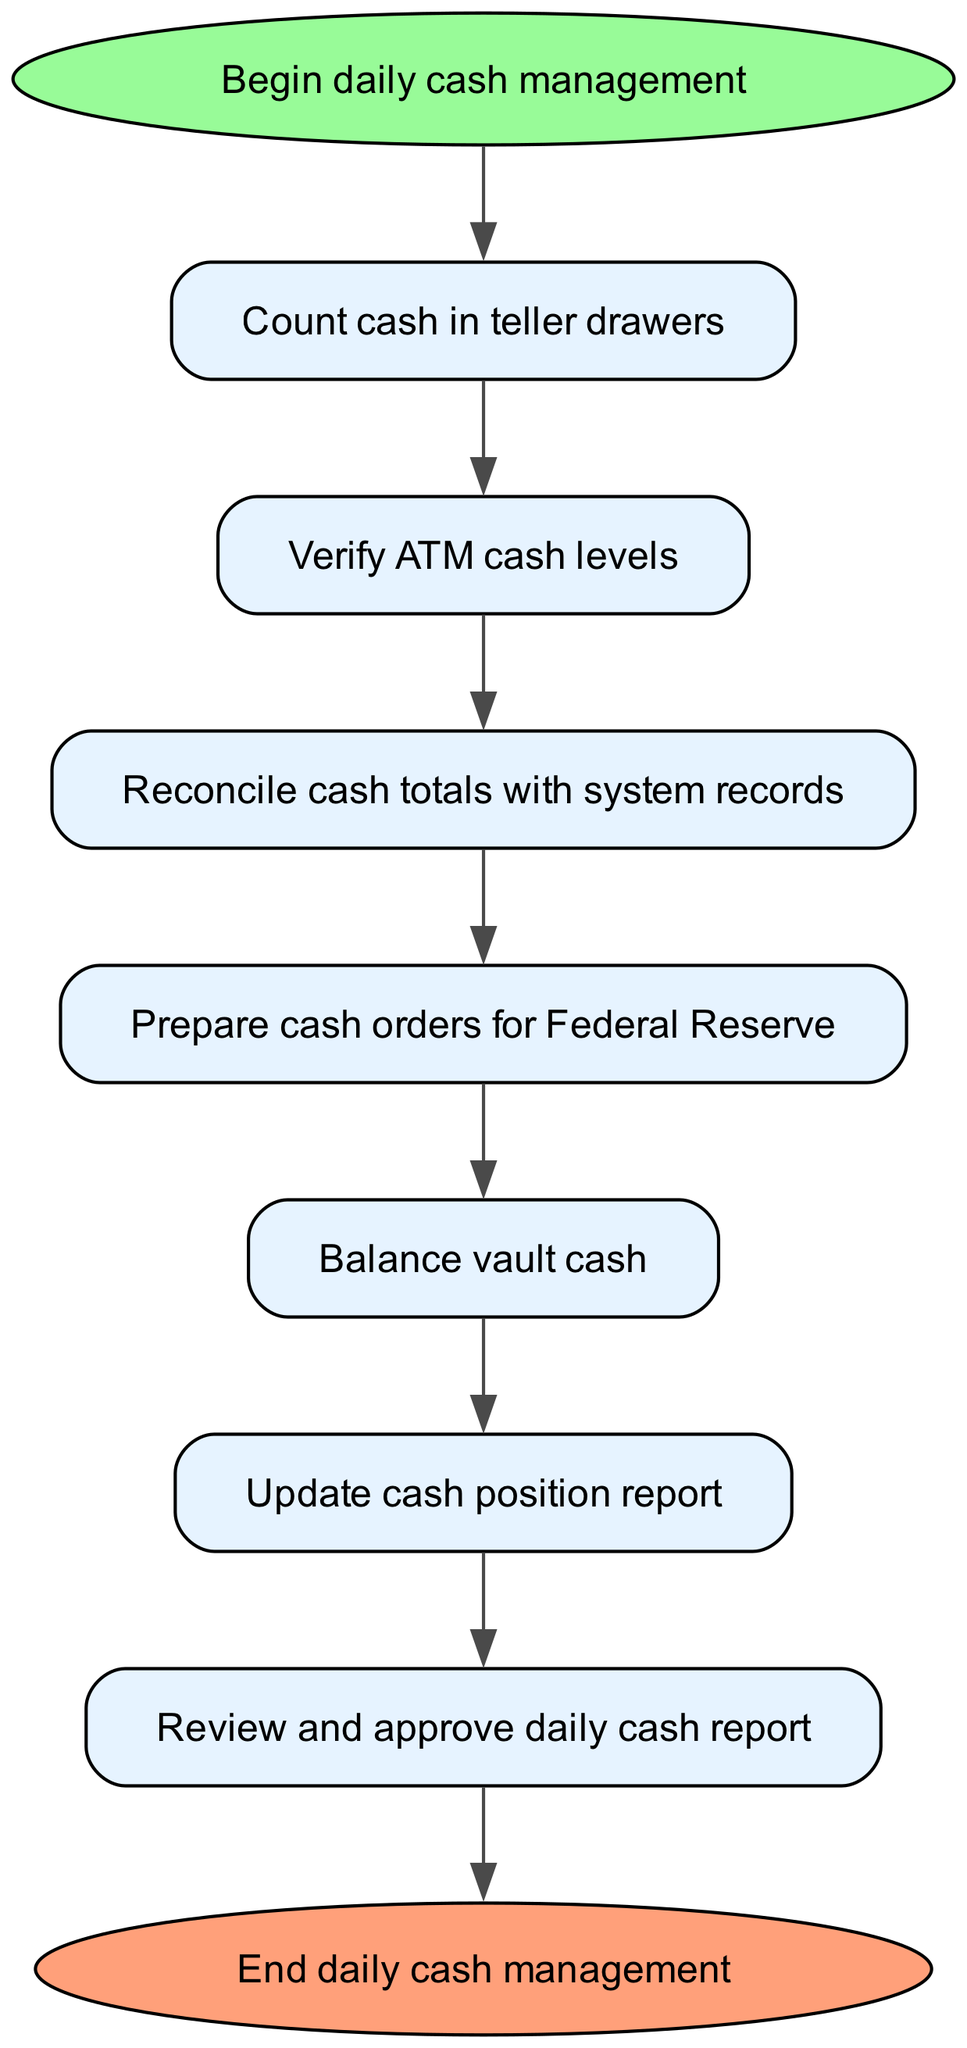What is the first step in daily cash management? The flowchart begins with the node labeled "Begin daily cash management," leading to the next step. The first detailed action mentioned directly after the start is "Count cash in teller drawers."
Answer: Count cash in teller drawers How many steps are there in the daily cash management process? The diagram outlines a series of steps that include counting cash, verifying ATM levels, reconciling totals, preparing orders, balancing vault cash, updating reports, and reviewing daily cash report, which totals to seven steps.
Answer: Seven What is the last action before ending daily cash management? The final action in the sequence before reaching "End daily cash management" is "Review and approve daily cash report." This indicates it is the last procedural check before completion.
Answer: Review and approve daily cash report What is the action taken after reconciling cash totals? After the action "Reconcile cash totals with system records," the subsequent action is to "Prepare cash orders for Federal Reserve," indicating it's a follow-up step in the cash management process.
Answer: Prepare cash orders for Federal Reserve Which action occurs right after verifying ATM cash levels? Following the action "Verify ATM cash levels," the next step in the flow is "Reconcile cash totals with system records," indicating that the process is sequential, moving from ATM verification to cash reconciliation.
Answer: Reconcile cash totals with system records What is the relationship between the "Count cash in teller drawers" and "Balance vault cash"? The first action, "Count cash in teller drawers," flows sequentially to "Verify ATM cash levels," and this process continues until it reaches "Balance vault cash." This reflects a continuous process wherein the outcomes of one step inform the next.
Answer: Sequential process How does the vault balancing step relate to the overall cash management process? The step "Balance vault cash" is part of the progression of actions in daily cash management. It follows after preparing cash orders and indicates a critical balance verification phase essential for maintaining the integrity of cash management.
Answer: Critical balance verification phase What color represents the start and end nodes in the diagram? The start node has a light green color, characterized by the fillcolor code #98FB98, while the end node is represented in a light coral color with the fillcolor code #FFA07A. These color codes differentiate the start and end of the process.
Answer: Light green and light coral 